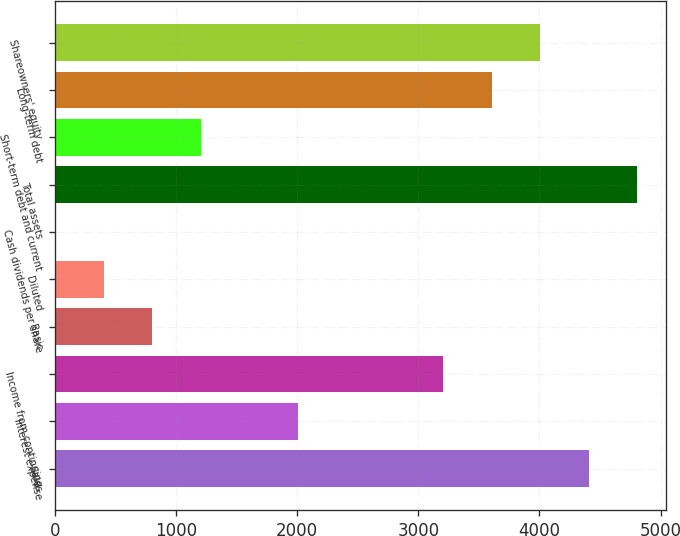Convert chart to OTSL. <chart><loc_0><loc_0><loc_500><loc_500><bar_chart><fcel>Sales<fcel>Interest expense<fcel>Income from continuing<fcel>Basic<fcel>Diluted<fcel>Cash dividends per share<fcel>Total assets<fcel>Short-term debt and current<fcel>Long-term debt<fcel>Shareowners' equity<nl><fcel>4406.82<fcel>2003.46<fcel>3205.14<fcel>801.78<fcel>401.22<fcel>0.66<fcel>4807.38<fcel>1202.34<fcel>3605.7<fcel>4006.26<nl></chart> 